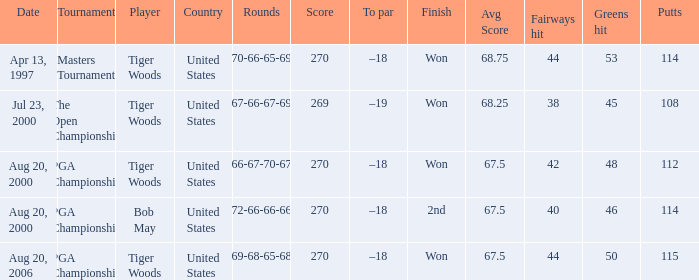Can you give me this table as a dict? {'header': ['Date', 'Tournament', 'Player', 'Country', 'Rounds', 'Score', 'To par', 'Finish', 'Avg Score', 'Fairways hit', 'Greens hit', 'Putts'], 'rows': [['Apr 13, 1997', 'Masters Tournament', 'Tiger Woods', 'United States', '70-66-65-69', '270', '–18', 'Won', '68.75', '44', '53', '114'], ['Jul 23, 2000', 'The Open Championship', 'Tiger Woods', 'United States', '67-66-67-69', '269', '–19', 'Won', '68.25', '38', '45', '108'], ['Aug 20, 2000', 'PGA Championship', 'Tiger Woods', 'United States', '66-67-70-67', '270', '–18', 'Won', '67.5', '42', '48', '112'], ['Aug 20, 2000', 'PGA Championship', 'Bob May', 'United States', '72-66-66-66', '270', '–18', '2nd', '67.5', '40', '46', '114'], ['Aug 20, 2006', 'PGA Championship', 'Tiger Woods', 'United States', '69-68-65-68', '270', '–18', 'Won', '67.5', '44', '50', '115']]} What is the worst (highest) score? 270.0. 